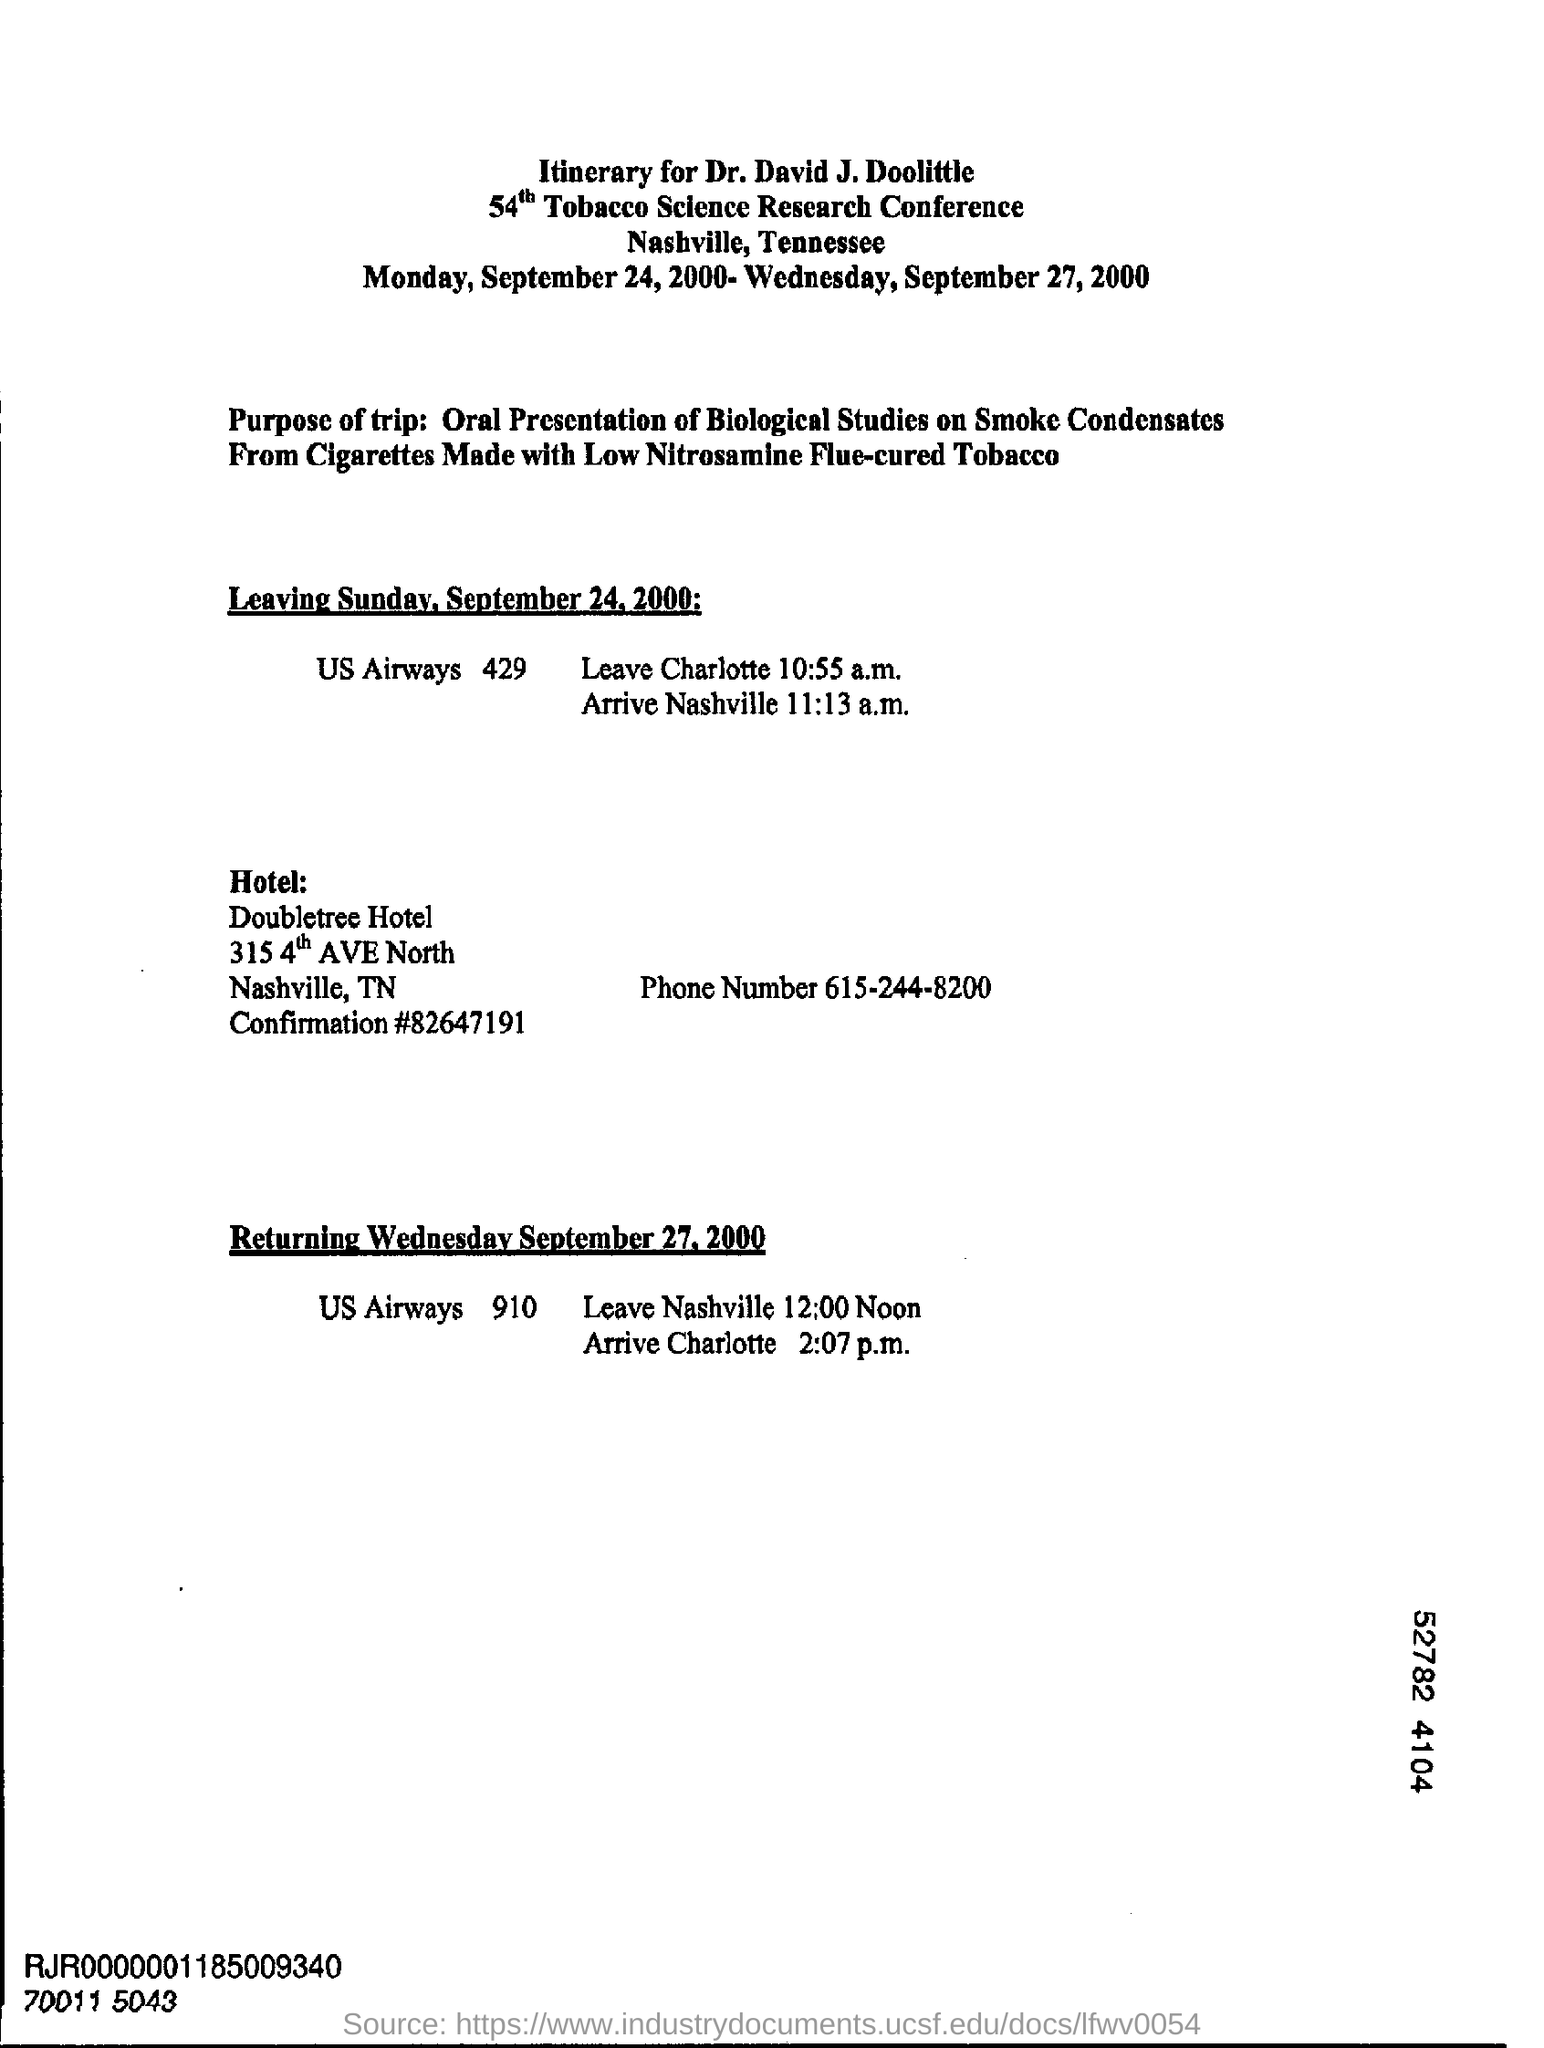Give some essential details in this illustration. Doubletree Hotel is located in the state of Tennessee. The phone number of the Doubletree hotel is 615-244-8200. 